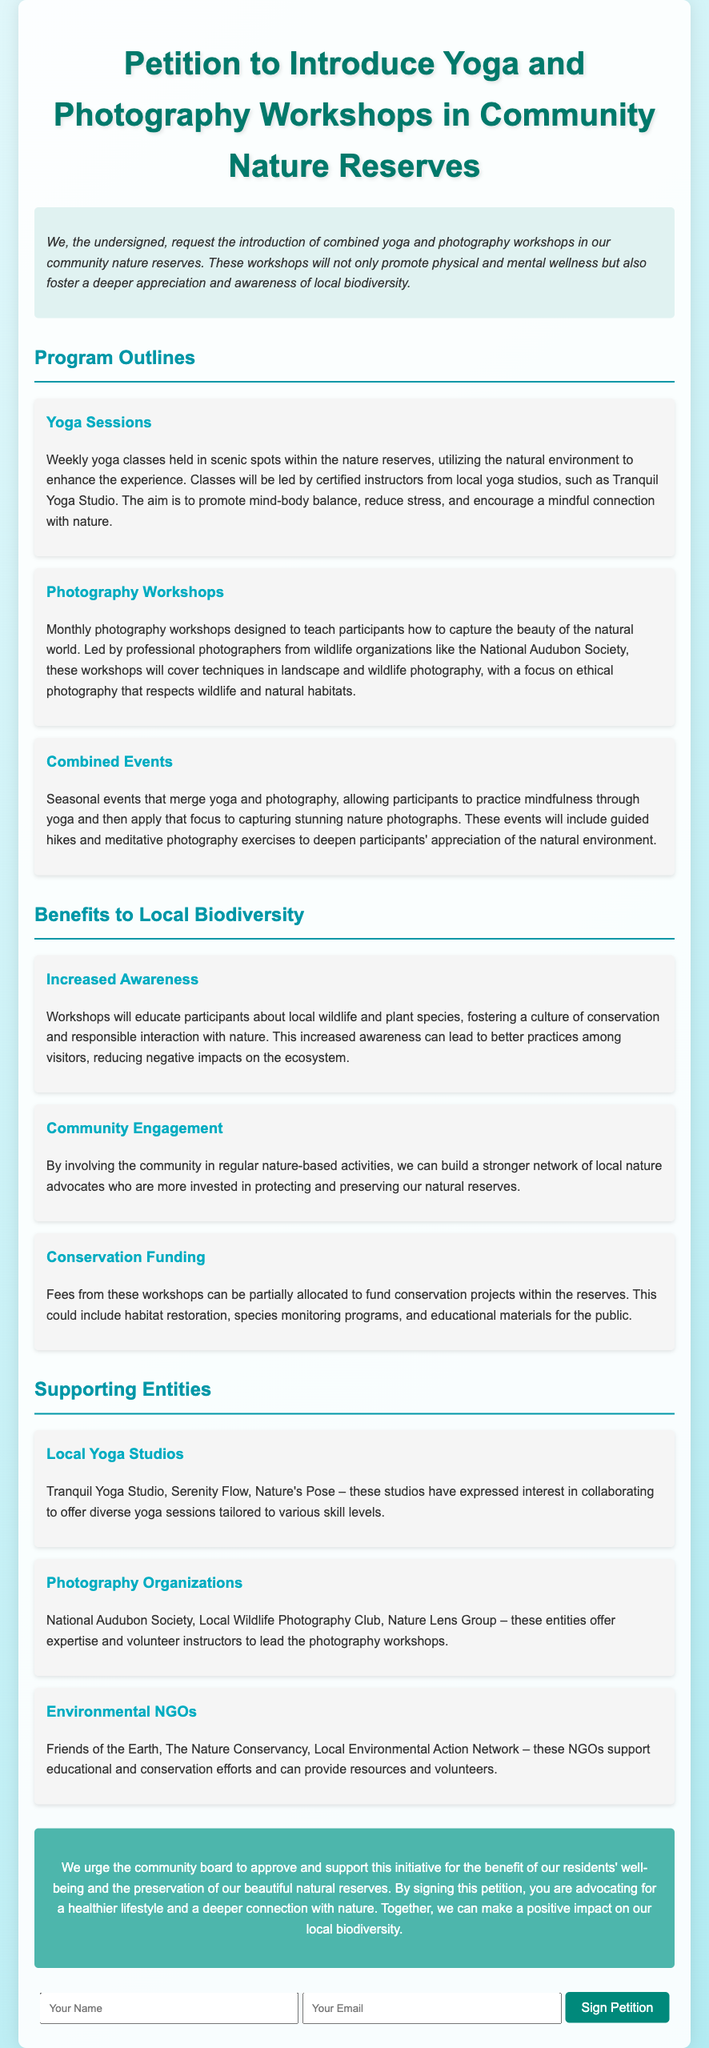What is the title of the petition? The title of the petition is prominently displayed at the top of the document.
Answer: Petition to Introduce Yoga and Photography Workshops in Community Nature Reserves Who leads the yoga sessions? The document states that classes will be led by certified instructors from local yoga studios.
Answer: Certified instructors How often will photography workshops be held? The document specifies the frequency of the photography workshops within the program outlines.
Answer: Monthly What organizations will support the photography workshops? The document mentions specific organizations that will offer expertise for the workshops.
Answer: National Audubon Society What is one benefit to local biodiversity mentioned? The document outlines various benefits to local biodiversity and names one specific benefit.
Answer: Increased Awareness Which local yoga studio expressed interest in collaborating? The document lists several local studios that have shown interest in the workshops.
Answer: Tranquil Yoga Studio What will fees from workshops partially fund? The document explains what the fees collected from the workshops will support.
Answer: Conservation projects What is the document's primary purpose? The petition clearly states the main aim behind its creation in the introduction.
Answer: Advocate for community workshops 